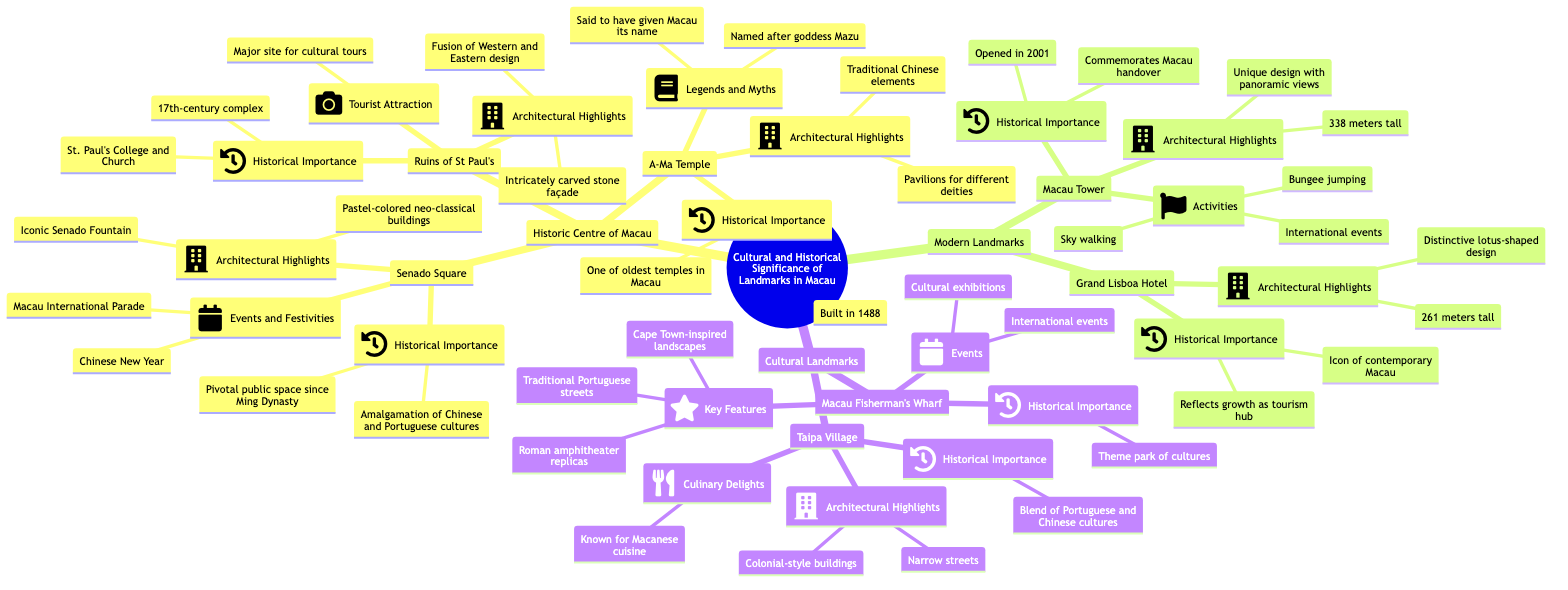What is the historical importance of Senado Square? The node for Senado Square highlights that it is a pivotal public space since the Ming Dynasty and represents the amalgamation of Chinese and Portuguese cultures.
Answer: Pivotal public space since Ming Dynasty, amalgamation of Chinese and Portuguese cultures How tall is the Macau Tower? The diagram indicates that the height of the Macau Tower is specifically stated as 338 meters.
Answer: 338 meters Which temple in Macau is said to have given the city its name? The diagram shows that the A-Ma Temple, named after the goddess Mazu, is said to have given Macau its name.
Answer: A-Ma Temple What is a feature of the Grand Lisboa Hotel's architectural design? According to the diagram, the Grand Lisboa Hotel has a distinctive lotus-shaped design.
Answer: Distinctive lotus-shaped design How many main categories of landmarks are represented in the diagram? The diagram shows there are three main categories: Historic Centre of Macau, Modern Landmarks, and Cultural Landmarks.
Answer: Three What type of events does Macau Fisherman's Wharf host? The node for Macau Fisherman's Wharf lists cultural exhibitions and international events, indicating the types of events held there.
Answer: Cultural exhibitions, international events During which festivities is Senado Square known to host events? Looking closely, the diagram mentions that Senado Square hosts events for the Chinese New Year and Macau International Parade.
Answer: Chinese New Year, Macau International Parade Which historic site features intricately carved stone façades? The Ruins of St Paul's are described in the diagram as having intricately carved stone façades, making them notable.
Answer: Ruins of St Paul's Which landmark in Macau was opened to commemorate the handover of Macau? The diagram specifies that the Macau Tower was opened in 2001 to commemorate the handover of Macau.
Answer: Macau Tower 